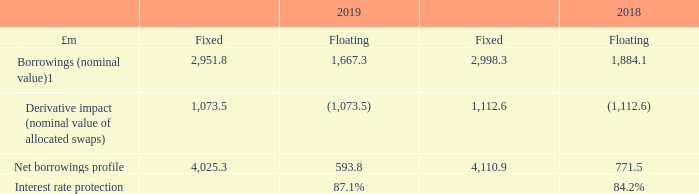27 Financial risk management
The Group is exposed to a variety of financial risks arising from the Group’s operations being principally market risk (including interest rate risk and foreign exchange risk), liquidity risk and credit risk.
The majority of the Group’s financial risk management is carried out by the Group’s treasury department. The policies for managing each of these risks and their impact on the results for the year are summarised below.
Market risk
a) Interest rate risk
Interest rate risk comprises both cash flow and fair value risks. Cash flow interest rate risk is the risk that the future cash flows of a financial instrument will fluctuate due to changes in market interest rates. Fair value interest rate risk is the risk that the fair value of financial instruments will fluctuate as a result of changes in market interest rates
The Group’s interest rate risk arises from borrowings issued at floating rates that expose the Group to cash flow interest rate risk, whereas borrowings issued at fixed interest rates expose the Group to fair value interest rate risk. Bank debt is typically issued at floating rates linked to LIBOR. The Group is aware that LIBOR will be discontinued after 2021 and is actively monitoring the output from the various working groups on LIBOR reform. The Group will also be carrying out a review on whether the fall-back provision across its existing facilities (including bank debt, floating rate notes and interest rate swaps) is adequate, and look to implement changes as and when it is appropriate. Bond debt and other capital market debt is generally issued at fixed rates.
It is Group policy, and often a requirement of the Group’s lenders, to eliminate substantially all exposure to interest rate fluctuations by using floating to fixed interest rate swaps (referred to as allocated swaps) in order to establish certainty over cash flows. Such allocated swaps have the economic effect of converting borrowings from floating to fixed rates. The Group also holds interest rate swaps that are not actively used as a hedge against borrowings (referred to as unallocated swaps).
As a consequence, the Group is exposed to market price risk in respect of the fair value of its fixed rate interest rate swaps. Additional information on the Group’s interest rate swaps is provided in the financial review on page 34
The table below shows the effects of allocated swaps on the borrowings profile of the Group:
Group policy is to target interest rate protection within the range of 75 per cent to 100 per cent
The weighted average rate for allocated swaps currently effective is 1.97 per cent (2018: 1.89 per cent).
The nominal value of unallocated swaps, which are excluded from the above table, is £483.4 million (2018: £566.7 million). Their fair value of £166.7 million (2018: £184.4 million) is included as a liability in the balance sheet. The term of each unallocated swap runs until its respective maturity date, the last of which runs until 2037, but each also has a mandatory or discretionary break clause which, unless otherwise agreed, would lead to earlier termination between 2020 and 2023. In the event of an early termination of an unallocated swap, a settlement amount is immediately payable by the Group.
The impact on the total fair value of derivatives liability and the inverse to change in fair value of financial instruments (allocated and unallocated swaps) of a 50 basis point increase in the level of interest rates would be a credit to the income statement and increase in equity of £67.8 million (2018: £78.8 million). The approximate impact of a 50-basis point reduction in the level of interest rates would be a charge to the income statement and decrease in equity of £67.8 million (2018: £78.8 million). In practice, a parallel shift in the yield curve is highly unlikely. However, the above sensitivity analysis is a reasonable illustration of the possible effect from the changes in slope and shifts in the yield curve that may occur. Where the fixed rate derivative financial instruments are matched by floating rate debt, the overall effect on Group cash flow of such a movement would be very small.
What does interest rate risk comprise of? Cash flow and fair value risks. What is the Group policy? To target interest rate protection within the range of 75 per cent to 100 per cent. What is the interest rate protection in 2019? 87.1%. What is the percentage change in the nominal value of unallocated swaps from 2018 to 2019?
Answer scale should be: percent. (483.4-566.7)/566.7
Answer: -14.7. What is the percentage change in the fair value of unallocated swaps from 2018 to 2019?
Answer scale should be: percent. (166.7-184.4)/184.4
Answer: -9.6. What is the change in interest rate protection between 2018 and 2019?
Answer scale should be: percent. 87.1%-84.2%
Answer: 2.9. 